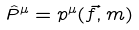Convert formula to latex. <formula><loc_0><loc_0><loc_500><loc_500>\hat { P } ^ { \mu } = p ^ { \mu } ( \vec { f } , m )</formula> 